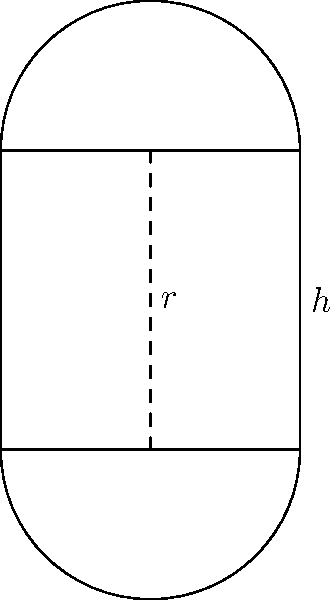As a junior software engineer working on an optimization problem, you need to determine the dimensions of a cylindrical can that will maximize its volume given a fixed surface area. The surface area of the can (including top and bottom) is 100π square units. Find the optimal radius and height of the can to maximize its volume. Round your answer to two decimal places. Let's approach this step-by-step:

1) First, let's define our variables:
   $r$ = radius of the base
   $h$ = height of the cylinder

2) The surface area of a cylinder (including top and bottom) is given by:
   $S = 2πr^2 + 2πrh = 100π$

3) The volume of a cylinder is given by:
   $V = πr^2h$

4) We want to express $h$ in terms of $r$ using the surface area equation:
   $2πr^2 + 2πrh = 100π$
   $2πrh = 100π - 2πr^2$
   $h = \frac{50}{r} - r$

5) Now we can express the volume solely in terms of $r$:
   $V = πr^2(\frac{50}{r} - r) = 50πr - πr^3$

6) To find the maximum volume, we need to differentiate $V$ with respect to $r$ and set it to zero:
   $\frac{dV}{dr} = 50π - 3πr^2 = 0$
   $50 - 3r^2 = 0$
   $r^2 = \frac{50}{3}$
   $r = \sqrt{\frac{50}{3}} ≈ 4.08$ units

7) Now we can find $h$:
   $h = \frac{50}{r} - r = \frac{50}{4.08} - 4.08 ≈ 8.16$ units

8) Rounding to two decimal places:
   $r ≈ 4.08$ units
   $h ≈ 8.16$ units
Answer: $r ≈ 4.08$ units, $h ≈ 8.16$ units 